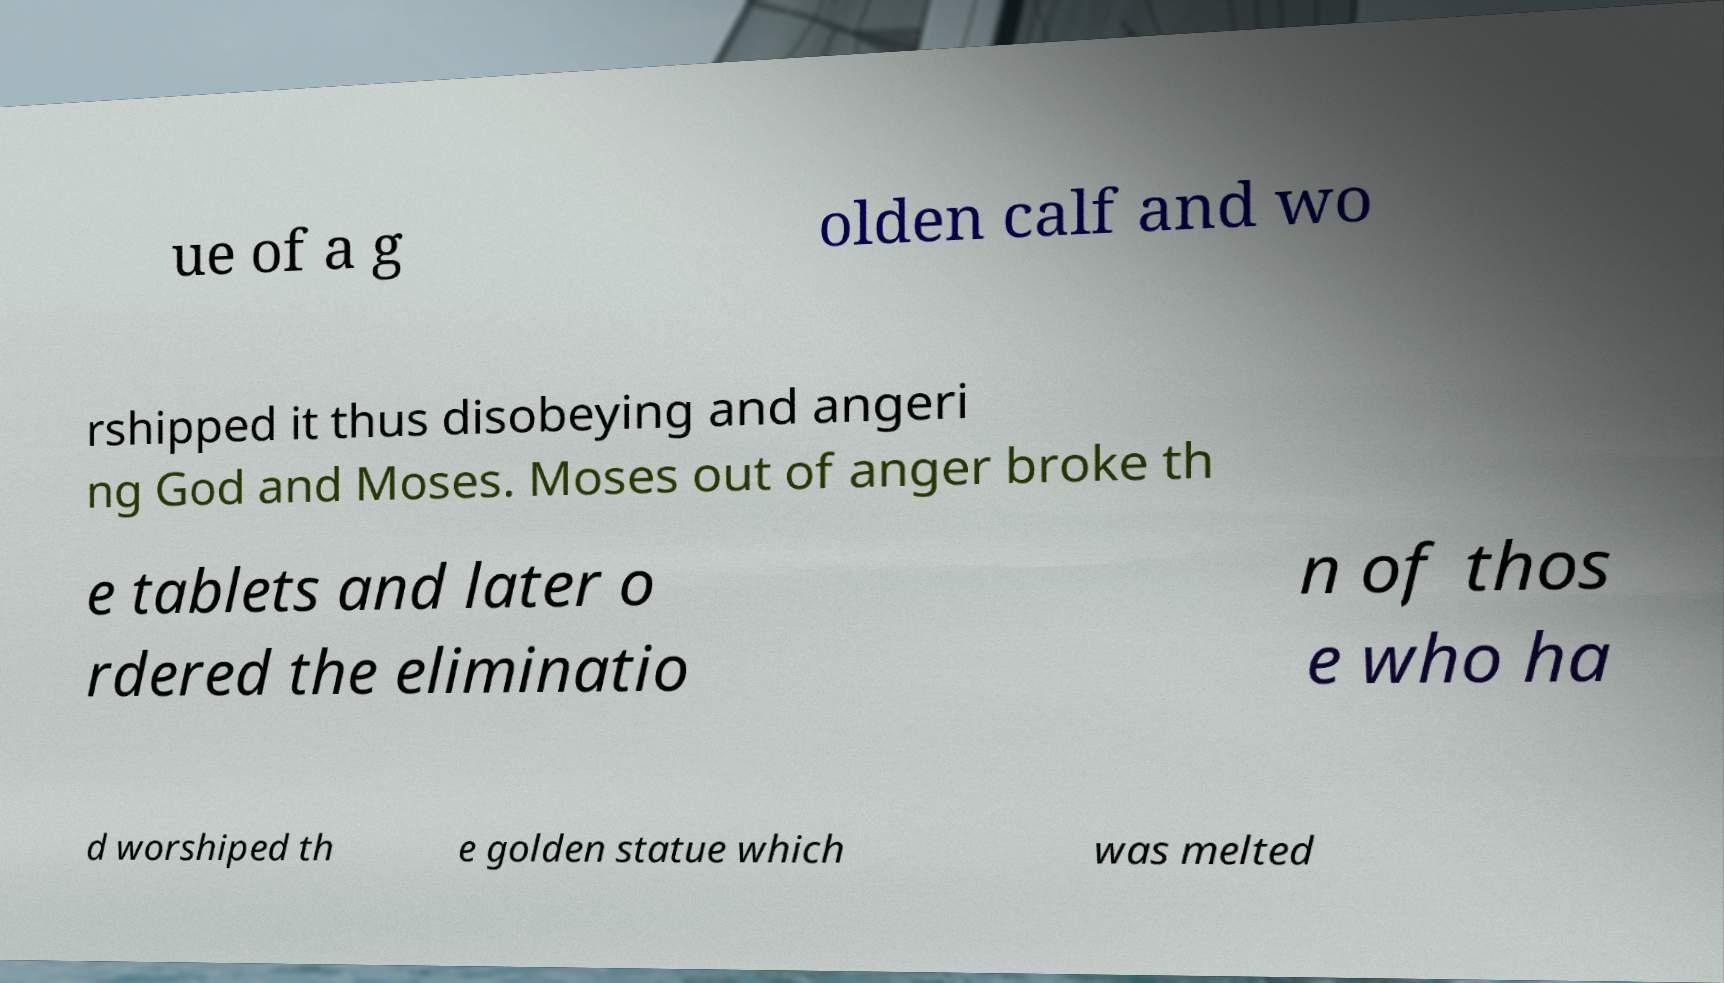Can you accurately transcribe the text from the provided image for me? ue of a g olden calf and wo rshipped it thus disobeying and angeri ng God and Moses. Moses out of anger broke th e tablets and later o rdered the eliminatio n of thos e who ha d worshiped th e golden statue which was melted 